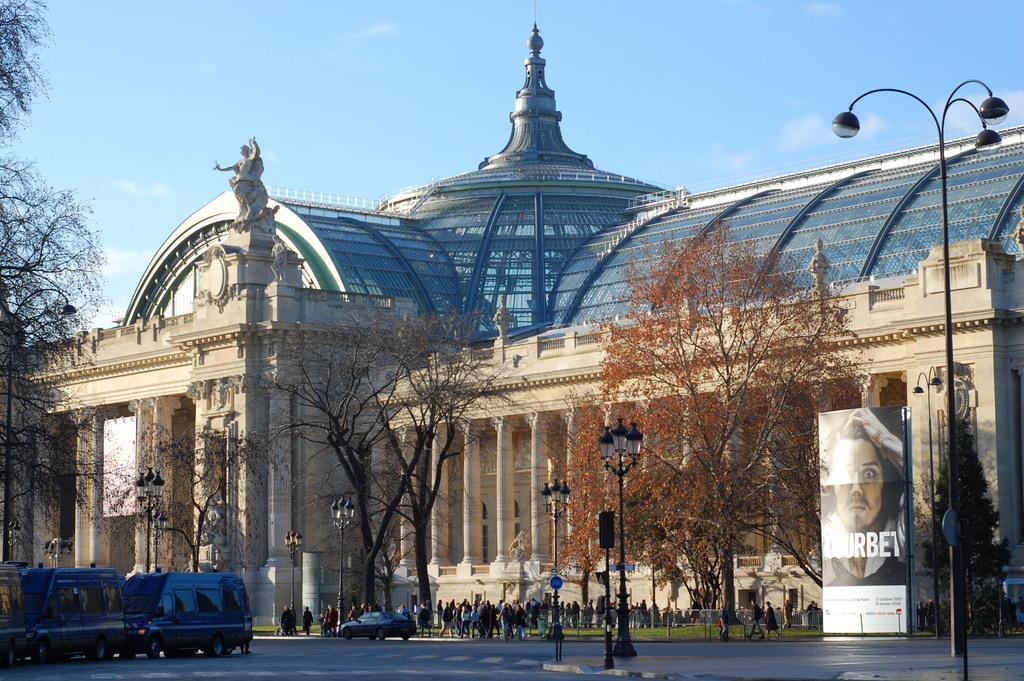How would you summarize this image in a sentence or two? In this picture I can observe building in the middle of the picture. In front of the people I can observe some people in the bottom of the picture. On the left side I can observe some vehicles on the road. In the background I can observe sky. 